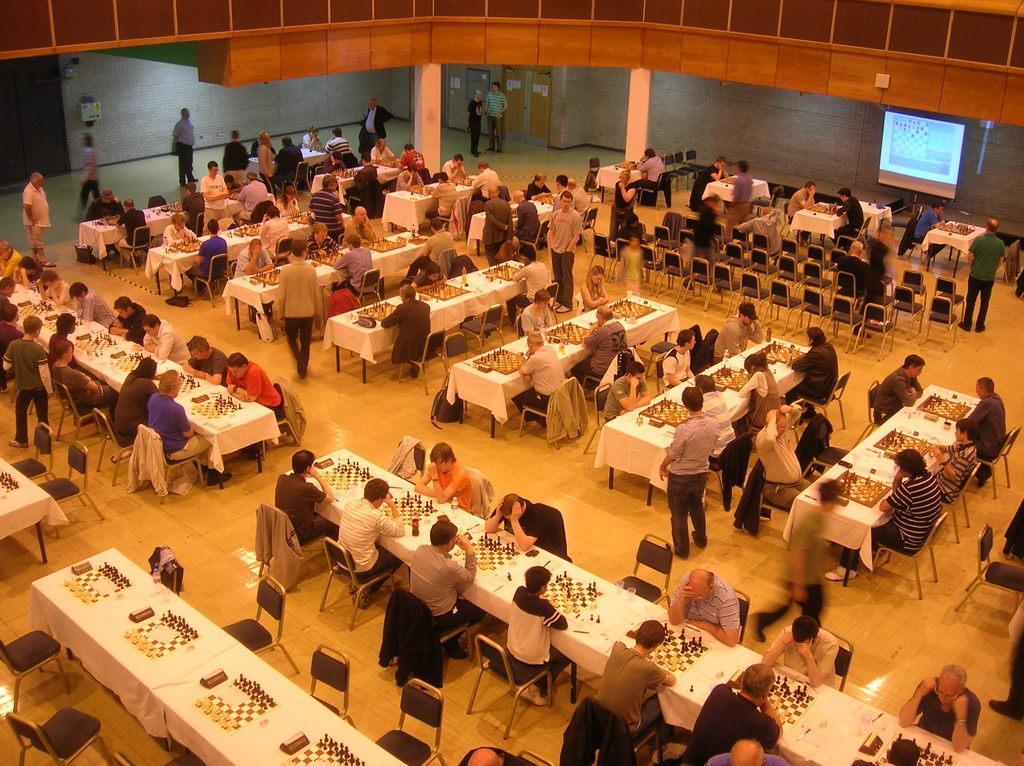Could you give a brief overview of what you see in this image? In this image, I can see groups of people sitting on the chairs and few people standing. There are chess boards with chess coins on the tables. At the top of the image, I can see a projector screen, pillars, door and a wall. 